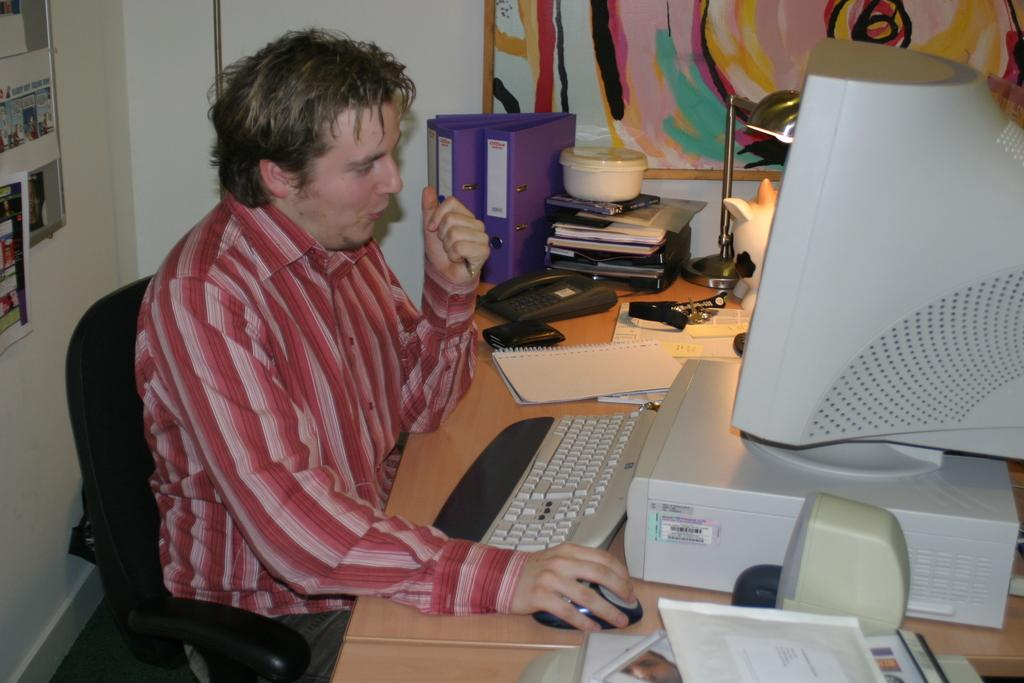Who is present in the image? There is a man in the image. What is the man doing in the image? The man is sitting on a chair. What objects are in front of the man? There is a monitor, a keyboard, a mouse, and a telephone in front of the man. What time of day is it in the bedroom in the image? There is no indication of a bedroom or a specific time of day in the image. The image only shows a man sitting in front of a monitor, keyboard, mouse, and telephone. 